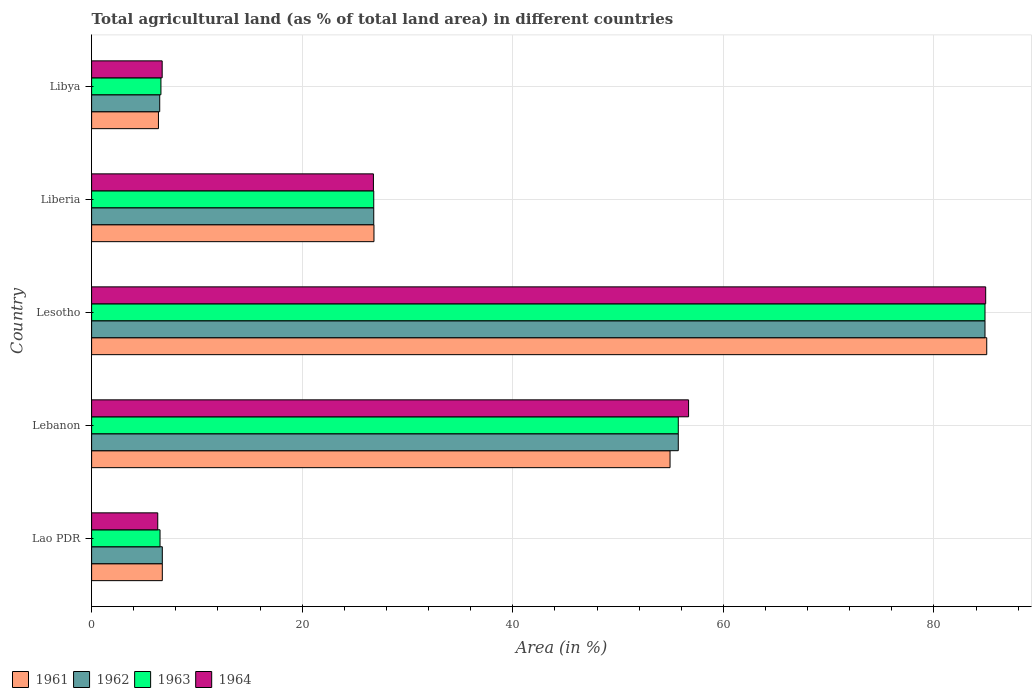Are the number of bars per tick equal to the number of legend labels?
Give a very brief answer. Yes. How many bars are there on the 4th tick from the bottom?
Your answer should be very brief. 4. What is the label of the 2nd group of bars from the top?
Keep it short and to the point. Liberia. In how many cases, is the number of bars for a given country not equal to the number of legend labels?
Make the answer very short. 0. What is the percentage of agricultural land in 1962 in Lesotho?
Offer a very short reply. 84.85. Across all countries, what is the maximum percentage of agricultural land in 1964?
Provide a short and direct response. 84.91. Across all countries, what is the minimum percentage of agricultural land in 1964?
Offer a terse response. 6.28. In which country was the percentage of agricultural land in 1963 maximum?
Provide a short and direct response. Lesotho. In which country was the percentage of agricultural land in 1964 minimum?
Your answer should be very brief. Lao PDR. What is the total percentage of agricultural land in 1964 in the graph?
Make the answer very short. 181.36. What is the difference between the percentage of agricultural land in 1961 in Lao PDR and that in Lebanon?
Offer a very short reply. -48.22. What is the difference between the percentage of agricultural land in 1963 in Lebanon and the percentage of agricultural land in 1962 in Libya?
Your answer should be compact. 49.25. What is the average percentage of agricultural land in 1961 per country?
Your answer should be compact. 35.97. What is the difference between the percentage of agricultural land in 1964 and percentage of agricultural land in 1962 in Lebanon?
Your answer should be compact. 0.98. What is the ratio of the percentage of agricultural land in 1962 in Lao PDR to that in Lebanon?
Your answer should be very brief. 0.12. What is the difference between the highest and the second highest percentage of agricultural land in 1962?
Your answer should be very brief. 29.13. What is the difference between the highest and the lowest percentage of agricultural land in 1962?
Your answer should be compact. 78.38. In how many countries, is the percentage of agricultural land in 1962 greater than the average percentage of agricultural land in 1962 taken over all countries?
Provide a succinct answer. 2. Is it the case that in every country, the sum of the percentage of agricultural land in 1961 and percentage of agricultural land in 1964 is greater than the percentage of agricultural land in 1963?
Your response must be concise. Yes. How many bars are there?
Your answer should be very brief. 20. Are all the bars in the graph horizontal?
Your answer should be compact. Yes. How many countries are there in the graph?
Your answer should be very brief. 5. What is the difference between two consecutive major ticks on the X-axis?
Your answer should be very brief. 20. Does the graph contain any zero values?
Your answer should be compact. No. How many legend labels are there?
Provide a short and direct response. 4. How are the legend labels stacked?
Your answer should be compact. Horizontal. What is the title of the graph?
Provide a short and direct response. Total agricultural land (as % of total land area) in different countries. What is the label or title of the X-axis?
Your answer should be very brief. Area (in %). What is the Area (in %) in 1961 in Lao PDR?
Offer a terse response. 6.72. What is the Area (in %) of 1962 in Lao PDR?
Offer a very short reply. 6.72. What is the Area (in %) of 1963 in Lao PDR?
Keep it short and to the point. 6.5. What is the Area (in %) in 1964 in Lao PDR?
Offer a terse response. 6.28. What is the Area (in %) of 1961 in Lebanon?
Offer a very short reply. 54.94. What is the Area (in %) in 1962 in Lebanon?
Keep it short and to the point. 55.72. What is the Area (in %) of 1963 in Lebanon?
Your response must be concise. 55.72. What is the Area (in %) of 1964 in Lebanon?
Your answer should be compact. 56.7. What is the Area (in %) of 1961 in Lesotho?
Provide a short and direct response. 85.01. What is the Area (in %) of 1962 in Lesotho?
Your response must be concise. 84.85. What is the Area (in %) in 1963 in Lesotho?
Provide a short and direct response. 84.85. What is the Area (in %) in 1964 in Lesotho?
Make the answer very short. 84.91. What is the Area (in %) of 1961 in Liberia?
Your answer should be very brief. 26.82. What is the Area (in %) in 1962 in Liberia?
Ensure brevity in your answer.  26.8. What is the Area (in %) in 1963 in Liberia?
Your answer should be very brief. 26.8. What is the Area (in %) in 1964 in Liberia?
Provide a short and direct response. 26.76. What is the Area (in %) of 1961 in Libya?
Ensure brevity in your answer.  6.35. What is the Area (in %) of 1962 in Libya?
Your response must be concise. 6.47. What is the Area (in %) in 1963 in Libya?
Your answer should be compact. 6.58. What is the Area (in %) in 1964 in Libya?
Make the answer very short. 6.7. Across all countries, what is the maximum Area (in %) in 1961?
Keep it short and to the point. 85.01. Across all countries, what is the maximum Area (in %) of 1962?
Your response must be concise. 84.85. Across all countries, what is the maximum Area (in %) in 1963?
Your answer should be compact. 84.85. Across all countries, what is the maximum Area (in %) of 1964?
Offer a terse response. 84.91. Across all countries, what is the minimum Area (in %) of 1961?
Keep it short and to the point. 6.35. Across all countries, what is the minimum Area (in %) of 1962?
Offer a terse response. 6.47. Across all countries, what is the minimum Area (in %) in 1963?
Offer a terse response. 6.5. Across all countries, what is the minimum Area (in %) in 1964?
Give a very brief answer. 6.28. What is the total Area (in %) of 1961 in the graph?
Keep it short and to the point. 179.83. What is the total Area (in %) in 1962 in the graph?
Offer a terse response. 180.55. What is the total Area (in %) of 1963 in the graph?
Provide a succinct answer. 180.45. What is the total Area (in %) of 1964 in the graph?
Provide a succinct answer. 181.36. What is the difference between the Area (in %) of 1961 in Lao PDR and that in Lebanon?
Offer a very short reply. -48.22. What is the difference between the Area (in %) in 1962 in Lao PDR and that in Lebanon?
Offer a terse response. -49. What is the difference between the Area (in %) of 1963 in Lao PDR and that in Lebanon?
Provide a succinct answer. -49.22. What is the difference between the Area (in %) of 1964 in Lao PDR and that in Lebanon?
Offer a terse response. -50.41. What is the difference between the Area (in %) of 1961 in Lao PDR and that in Lesotho?
Give a very brief answer. -78.3. What is the difference between the Area (in %) in 1962 in Lao PDR and that in Lesotho?
Ensure brevity in your answer.  -78.13. What is the difference between the Area (in %) in 1963 in Lao PDR and that in Lesotho?
Give a very brief answer. -78.35. What is the difference between the Area (in %) in 1964 in Lao PDR and that in Lesotho?
Ensure brevity in your answer.  -78.63. What is the difference between the Area (in %) in 1961 in Lao PDR and that in Liberia?
Your answer should be compact. -20.1. What is the difference between the Area (in %) of 1962 in Lao PDR and that in Liberia?
Your answer should be very brief. -20.08. What is the difference between the Area (in %) in 1963 in Lao PDR and that in Liberia?
Offer a terse response. -20.3. What is the difference between the Area (in %) of 1964 in Lao PDR and that in Liberia?
Provide a succinct answer. -20.48. What is the difference between the Area (in %) in 1961 in Lao PDR and that in Libya?
Give a very brief answer. 0.37. What is the difference between the Area (in %) in 1962 in Lao PDR and that in Libya?
Provide a succinct answer. 0.25. What is the difference between the Area (in %) in 1963 in Lao PDR and that in Libya?
Provide a short and direct response. -0.09. What is the difference between the Area (in %) of 1964 in Lao PDR and that in Libya?
Your answer should be compact. -0.42. What is the difference between the Area (in %) of 1961 in Lebanon and that in Lesotho?
Offer a very short reply. -30.08. What is the difference between the Area (in %) of 1962 in Lebanon and that in Lesotho?
Provide a short and direct response. -29.13. What is the difference between the Area (in %) in 1963 in Lebanon and that in Lesotho?
Provide a short and direct response. -29.13. What is the difference between the Area (in %) in 1964 in Lebanon and that in Lesotho?
Keep it short and to the point. -28.22. What is the difference between the Area (in %) in 1961 in Lebanon and that in Liberia?
Make the answer very short. 28.12. What is the difference between the Area (in %) of 1962 in Lebanon and that in Liberia?
Give a very brief answer. 28.92. What is the difference between the Area (in %) of 1963 in Lebanon and that in Liberia?
Ensure brevity in your answer.  28.92. What is the difference between the Area (in %) of 1964 in Lebanon and that in Liberia?
Your response must be concise. 29.93. What is the difference between the Area (in %) in 1961 in Lebanon and that in Libya?
Your answer should be very brief. 48.59. What is the difference between the Area (in %) in 1962 in Lebanon and that in Libya?
Give a very brief answer. 49.25. What is the difference between the Area (in %) in 1963 in Lebanon and that in Libya?
Provide a succinct answer. 49.13. What is the difference between the Area (in %) in 1964 in Lebanon and that in Libya?
Provide a short and direct response. 49.99. What is the difference between the Area (in %) in 1961 in Lesotho and that in Liberia?
Your response must be concise. 58.2. What is the difference between the Area (in %) in 1962 in Lesotho and that in Liberia?
Your answer should be very brief. 58.05. What is the difference between the Area (in %) of 1963 in Lesotho and that in Liberia?
Provide a short and direct response. 58.05. What is the difference between the Area (in %) in 1964 in Lesotho and that in Liberia?
Provide a short and direct response. 58.15. What is the difference between the Area (in %) of 1961 in Lesotho and that in Libya?
Keep it short and to the point. 78.66. What is the difference between the Area (in %) in 1962 in Lesotho and that in Libya?
Your response must be concise. 78.38. What is the difference between the Area (in %) in 1963 in Lesotho and that in Libya?
Offer a very short reply. 78.26. What is the difference between the Area (in %) of 1964 in Lesotho and that in Libya?
Provide a succinct answer. 78.21. What is the difference between the Area (in %) of 1961 in Liberia and that in Libya?
Make the answer very short. 20.47. What is the difference between the Area (in %) in 1962 in Liberia and that in Libya?
Ensure brevity in your answer.  20.33. What is the difference between the Area (in %) of 1963 in Liberia and that in Libya?
Make the answer very short. 20.21. What is the difference between the Area (in %) of 1964 in Liberia and that in Libya?
Offer a very short reply. 20.06. What is the difference between the Area (in %) of 1961 in Lao PDR and the Area (in %) of 1962 in Lebanon?
Your response must be concise. -49. What is the difference between the Area (in %) of 1961 in Lao PDR and the Area (in %) of 1963 in Lebanon?
Offer a very short reply. -49. What is the difference between the Area (in %) in 1961 in Lao PDR and the Area (in %) in 1964 in Lebanon?
Your answer should be very brief. -49.98. What is the difference between the Area (in %) of 1962 in Lao PDR and the Area (in %) of 1963 in Lebanon?
Your answer should be very brief. -49. What is the difference between the Area (in %) of 1962 in Lao PDR and the Area (in %) of 1964 in Lebanon?
Offer a very short reply. -49.98. What is the difference between the Area (in %) of 1963 in Lao PDR and the Area (in %) of 1964 in Lebanon?
Keep it short and to the point. -50.2. What is the difference between the Area (in %) of 1961 in Lao PDR and the Area (in %) of 1962 in Lesotho?
Your answer should be compact. -78.13. What is the difference between the Area (in %) in 1961 in Lao PDR and the Area (in %) in 1963 in Lesotho?
Provide a succinct answer. -78.13. What is the difference between the Area (in %) of 1961 in Lao PDR and the Area (in %) of 1964 in Lesotho?
Give a very brief answer. -78.2. What is the difference between the Area (in %) of 1962 in Lao PDR and the Area (in %) of 1963 in Lesotho?
Your answer should be compact. -78.13. What is the difference between the Area (in %) of 1962 in Lao PDR and the Area (in %) of 1964 in Lesotho?
Your answer should be compact. -78.2. What is the difference between the Area (in %) of 1963 in Lao PDR and the Area (in %) of 1964 in Lesotho?
Make the answer very short. -78.42. What is the difference between the Area (in %) in 1961 in Lao PDR and the Area (in %) in 1962 in Liberia?
Provide a succinct answer. -20.08. What is the difference between the Area (in %) in 1961 in Lao PDR and the Area (in %) in 1963 in Liberia?
Ensure brevity in your answer.  -20.08. What is the difference between the Area (in %) in 1961 in Lao PDR and the Area (in %) in 1964 in Liberia?
Offer a very short reply. -20.05. What is the difference between the Area (in %) of 1962 in Lao PDR and the Area (in %) of 1963 in Liberia?
Ensure brevity in your answer.  -20.08. What is the difference between the Area (in %) in 1962 in Lao PDR and the Area (in %) in 1964 in Liberia?
Your response must be concise. -20.05. What is the difference between the Area (in %) of 1963 in Lao PDR and the Area (in %) of 1964 in Liberia?
Keep it short and to the point. -20.27. What is the difference between the Area (in %) of 1961 in Lao PDR and the Area (in %) of 1962 in Libya?
Offer a very short reply. 0.25. What is the difference between the Area (in %) of 1961 in Lao PDR and the Area (in %) of 1963 in Libya?
Make the answer very short. 0.13. What is the difference between the Area (in %) of 1961 in Lao PDR and the Area (in %) of 1964 in Libya?
Give a very brief answer. 0.01. What is the difference between the Area (in %) in 1962 in Lao PDR and the Area (in %) in 1963 in Libya?
Ensure brevity in your answer.  0.13. What is the difference between the Area (in %) of 1962 in Lao PDR and the Area (in %) of 1964 in Libya?
Ensure brevity in your answer.  0.01. What is the difference between the Area (in %) in 1963 in Lao PDR and the Area (in %) in 1964 in Libya?
Ensure brevity in your answer.  -0.2. What is the difference between the Area (in %) in 1961 in Lebanon and the Area (in %) in 1962 in Lesotho?
Provide a short and direct response. -29.91. What is the difference between the Area (in %) of 1961 in Lebanon and the Area (in %) of 1963 in Lesotho?
Provide a succinct answer. -29.91. What is the difference between the Area (in %) in 1961 in Lebanon and the Area (in %) in 1964 in Lesotho?
Make the answer very short. -29.98. What is the difference between the Area (in %) in 1962 in Lebanon and the Area (in %) in 1963 in Lesotho?
Your answer should be very brief. -29.13. What is the difference between the Area (in %) in 1962 in Lebanon and the Area (in %) in 1964 in Lesotho?
Provide a short and direct response. -29.2. What is the difference between the Area (in %) of 1963 in Lebanon and the Area (in %) of 1964 in Lesotho?
Your response must be concise. -29.2. What is the difference between the Area (in %) in 1961 in Lebanon and the Area (in %) in 1962 in Liberia?
Ensure brevity in your answer.  28.14. What is the difference between the Area (in %) of 1961 in Lebanon and the Area (in %) of 1963 in Liberia?
Provide a succinct answer. 28.14. What is the difference between the Area (in %) of 1961 in Lebanon and the Area (in %) of 1964 in Liberia?
Offer a very short reply. 28.17. What is the difference between the Area (in %) in 1962 in Lebanon and the Area (in %) in 1963 in Liberia?
Your answer should be compact. 28.92. What is the difference between the Area (in %) in 1962 in Lebanon and the Area (in %) in 1964 in Liberia?
Keep it short and to the point. 28.95. What is the difference between the Area (in %) in 1963 in Lebanon and the Area (in %) in 1964 in Liberia?
Provide a succinct answer. 28.95. What is the difference between the Area (in %) in 1961 in Lebanon and the Area (in %) in 1962 in Libya?
Provide a short and direct response. 48.47. What is the difference between the Area (in %) in 1961 in Lebanon and the Area (in %) in 1963 in Libya?
Keep it short and to the point. 48.35. What is the difference between the Area (in %) in 1961 in Lebanon and the Area (in %) in 1964 in Libya?
Your response must be concise. 48.23. What is the difference between the Area (in %) in 1962 in Lebanon and the Area (in %) in 1963 in Libya?
Offer a very short reply. 49.13. What is the difference between the Area (in %) of 1962 in Lebanon and the Area (in %) of 1964 in Libya?
Give a very brief answer. 49.02. What is the difference between the Area (in %) of 1963 in Lebanon and the Area (in %) of 1964 in Libya?
Your answer should be very brief. 49.02. What is the difference between the Area (in %) of 1961 in Lesotho and the Area (in %) of 1962 in Liberia?
Offer a terse response. 58.22. What is the difference between the Area (in %) in 1961 in Lesotho and the Area (in %) in 1963 in Liberia?
Ensure brevity in your answer.  58.22. What is the difference between the Area (in %) in 1961 in Lesotho and the Area (in %) in 1964 in Liberia?
Offer a very short reply. 58.25. What is the difference between the Area (in %) of 1962 in Lesotho and the Area (in %) of 1963 in Liberia?
Give a very brief answer. 58.05. What is the difference between the Area (in %) in 1962 in Lesotho and the Area (in %) in 1964 in Liberia?
Provide a short and direct response. 58.08. What is the difference between the Area (in %) of 1963 in Lesotho and the Area (in %) of 1964 in Liberia?
Keep it short and to the point. 58.08. What is the difference between the Area (in %) of 1961 in Lesotho and the Area (in %) of 1962 in Libya?
Offer a very short reply. 78.54. What is the difference between the Area (in %) in 1961 in Lesotho and the Area (in %) in 1963 in Libya?
Keep it short and to the point. 78.43. What is the difference between the Area (in %) of 1961 in Lesotho and the Area (in %) of 1964 in Libya?
Provide a succinct answer. 78.31. What is the difference between the Area (in %) in 1962 in Lesotho and the Area (in %) in 1963 in Libya?
Provide a short and direct response. 78.26. What is the difference between the Area (in %) of 1962 in Lesotho and the Area (in %) of 1964 in Libya?
Ensure brevity in your answer.  78.15. What is the difference between the Area (in %) in 1963 in Lesotho and the Area (in %) in 1964 in Libya?
Keep it short and to the point. 78.15. What is the difference between the Area (in %) of 1961 in Liberia and the Area (in %) of 1962 in Libya?
Offer a very short reply. 20.35. What is the difference between the Area (in %) of 1961 in Liberia and the Area (in %) of 1963 in Libya?
Provide a short and direct response. 20.23. What is the difference between the Area (in %) in 1961 in Liberia and the Area (in %) in 1964 in Libya?
Make the answer very short. 20.11. What is the difference between the Area (in %) of 1962 in Liberia and the Area (in %) of 1963 in Libya?
Ensure brevity in your answer.  20.21. What is the difference between the Area (in %) of 1962 in Liberia and the Area (in %) of 1964 in Libya?
Your response must be concise. 20.09. What is the difference between the Area (in %) in 1963 in Liberia and the Area (in %) in 1964 in Libya?
Offer a very short reply. 20.09. What is the average Area (in %) of 1961 per country?
Your answer should be compact. 35.97. What is the average Area (in %) in 1962 per country?
Offer a terse response. 36.11. What is the average Area (in %) in 1963 per country?
Ensure brevity in your answer.  36.09. What is the average Area (in %) of 1964 per country?
Give a very brief answer. 36.27. What is the difference between the Area (in %) of 1961 and Area (in %) of 1963 in Lao PDR?
Ensure brevity in your answer.  0.22. What is the difference between the Area (in %) in 1961 and Area (in %) in 1964 in Lao PDR?
Make the answer very short. 0.43. What is the difference between the Area (in %) of 1962 and Area (in %) of 1963 in Lao PDR?
Give a very brief answer. 0.22. What is the difference between the Area (in %) of 1962 and Area (in %) of 1964 in Lao PDR?
Ensure brevity in your answer.  0.43. What is the difference between the Area (in %) of 1963 and Area (in %) of 1964 in Lao PDR?
Provide a succinct answer. 0.22. What is the difference between the Area (in %) of 1961 and Area (in %) of 1962 in Lebanon?
Your answer should be compact. -0.78. What is the difference between the Area (in %) of 1961 and Area (in %) of 1963 in Lebanon?
Make the answer very short. -0.78. What is the difference between the Area (in %) of 1961 and Area (in %) of 1964 in Lebanon?
Make the answer very short. -1.76. What is the difference between the Area (in %) of 1962 and Area (in %) of 1963 in Lebanon?
Ensure brevity in your answer.  0. What is the difference between the Area (in %) in 1962 and Area (in %) in 1964 in Lebanon?
Your answer should be very brief. -0.98. What is the difference between the Area (in %) of 1963 and Area (in %) of 1964 in Lebanon?
Your answer should be compact. -0.98. What is the difference between the Area (in %) of 1961 and Area (in %) of 1962 in Lesotho?
Offer a very short reply. 0.16. What is the difference between the Area (in %) of 1961 and Area (in %) of 1963 in Lesotho?
Provide a short and direct response. 0.16. What is the difference between the Area (in %) in 1961 and Area (in %) in 1964 in Lesotho?
Give a very brief answer. 0.1. What is the difference between the Area (in %) in 1962 and Area (in %) in 1963 in Lesotho?
Ensure brevity in your answer.  0. What is the difference between the Area (in %) in 1962 and Area (in %) in 1964 in Lesotho?
Offer a very short reply. -0.07. What is the difference between the Area (in %) in 1963 and Area (in %) in 1964 in Lesotho?
Make the answer very short. -0.07. What is the difference between the Area (in %) of 1961 and Area (in %) of 1962 in Liberia?
Offer a terse response. 0.02. What is the difference between the Area (in %) of 1961 and Area (in %) of 1963 in Liberia?
Your answer should be compact. 0.02. What is the difference between the Area (in %) of 1961 and Area (in %) of 1964 in Liberia?
Your answer should be very brief. 0.05. What is the difference between the Area (in %) of 1962 and Area (in %) of 1964 in Liberia?
Your answer should be very brief. 0.03. What is the difference between the Area (in %) in 1963 and Area (in %) in 1964 in Liberia?
Offer a very short reply. 0.03. What is the difference between the Area (in %) in 1961 and Area (in %) in 1962 in Libya?
Make the answer very short. -0.12. What is the difference between the Area (in %) in 1961 and Area (in %) in 1963 in Libya?
Offer a terse response. -0.24. What is the difference between the Area (in %) in 1961 and Area (in %) in 1964 in Libya?
Provide a succinct answer. -0.35. What is the difference between the Area (in %) in 1962 and Area (in %) in 1963 in Libya?
Give a very brief answer. -0.11. What is the difference between the Area (in %) of 1962 and Area (in %) of 1964 in Libya?
Offer a terse response. -0.23. What is the difference between the Area (in %) in 1963 and Area (in %) in 1964 in Libya?
Offer a terse response. -0.12. What is the ratio of the Area (in %) of 1961 in Lao PDR to that in Lebanon?
Make the answer very short. 0.12. What is the ratio of the Area (in %) of 1962 in Lao PDR to that in Lebanon?
Offer a terse response. 0.12. What is the ratio of the Area (in %) of 1963 in Lao PDR to that in Lebanon?
Offer a terse response. 0.12. What is the ratio of the Area (in %) in 1964 in Lao PDR to that in Lebanon?
Provide a short and direct response. 0.11. What is the ratio of the Area (in %) of 1961 in Lao PDR to that in Lesotho?
Provide a short and direct response. 0.08. What is the ratio of the Area (in %) in 1962 in Lao PDR to that in Lesotho?
Provide a short and direct response. 0.08. What is the ratio of the Area (in %) in 1963 in Lao PDR to that in Lesotho?
Ensure brevity in your answer.  0.08. What is the ratio of the Area (in %) in 1964 in Lao PDR to that in Lesotho?
Your response must be concise. 0.07. What is the ratio of the Area (in %) in 1961 in Lao PDR to that in Liberia?
Your response must be concise. 0.25. What is the ratio of the Area (in %) in 1962 in Lao PDR to that in Liberia?
Provide a succinct answer. 0.25. What is the ratio of the Area (in %) in 1963 in Lao PDR to that in Liberia?
Provide a short and direct response. 0.24. What is the ratio of the Area (in %) of 1964 in Lao PDR to that in Liberia?
Your response must be concise. 0.23. What is the ratio of the Area (in %) in 1961 in Lao PDR to that in Libya?
Offer a terse response. 1.06. What is the ratio of the Area (in %) of 1962 in Lao PDR to that in Libya?
Ensure brevity in your answer.  1.04. What is the ratio of the Area (in %) of 1963 in Lao PDR to that in Libya?
Ensure brevity in your answer.  0.99. What is the ratio of the Area (in %) in 1964 in Lao PDR to that in Libya?
Your response must be concise. 0.94. What is the ratio of the Area (in %) of 1961 in Lebanon to that in Lesotho?
Offer a very short reply. 0.65. What is the ratio of the Area (in %) of 1962 in Lebanon to that in Lesotho?
Provide a succinct answer. 0.66. What is the ratio of the Area (in %) of 1963 in Lebanon to that in Lesotho?
Make the answer very short. 0.66. What is the ratio of the Area (in %) of 1964 in Lebanon to that in Lesotho?
Ensure brevity in your answer.  0.67. What is the ratio of the Area (in %) in 1961 in Lebanon to that in Liberia?
Provide a short and direct response. 2.05. What is the ratio of the Area (in %) in 1962 in Lebanon to that in Liberia?
Your response must be concise. 2.08. What is the ratio of the Area (in %) in 1963 in Lebanon to that in Liberia?
Offer a terse response. 2.08. What is the ratio of the Area (in %) of 1964 in Lebanon to that in Liberia?
Offer a very short reply. 2.12. What is the ratio of the Area (in %) in 1961 in Lebanon to that in Libya?
Keep it short and to the point. 8.65. What is the ratio of the Area (in %) of 1962 in Lebanon to that in Libya?
Provide a short and direct response. 8.61. What is the ratio of the Area (in %) of 1963 in Lebanon to that in Libya?
Your response must be concise. 8.46. What is the ratio of the Area (in %) in 1964 in Lebanon to that in Libya?
Ensure brevity in your answer.  8.46. What is the ratio of the Area (in %) in 1961 in Lesotho to that in Liberia?
Offer a very short reply. 3.17. What is the ratio of the Area (in %) in 1962 in Lesotho to that in Liberia?
Offer a very short reply. 3.17. What is the ratio of the Area (in %) of 1963 in Lesotho to that in Liberia?
Provide a succinct answer. 3.17. What is the ratio of the Area (in %) of 1964 in Lesotho to that in Liberia?
Offer a terse response. 3.17. What is the ratio of the Area (in %) of 1961 in Lesotho to that in Libya?
Give a very brief answer. 13.39. What is the ratio of the Area (in %) of 1962 in Lesotho to that in Libya?
Your answer should be very brief. 13.12. What is the ratio of the Area (in %) in 1963 in Lesotho to that in Libya?
Your response must be concise. 12.89. What is the ratio of the Area (in %) in 1964 in Lesotho to that in Libya?
Your response must be concise. 12.67. What is the ratio of the Area (in %) of 1961 in Liberia to that in Libya?
Provide a succinct answer. 4.22. What is the ratio of the Area (in %) of 1962 in Liberia to that in Libya?
Provide a succinct answer. 4.14. What is the ratio of the Area (in %) in 1963 in Liberia to that in Libya?
Provide a short and direct response. 4.07. What is the ratio of the Area (in %) of 1964 in Liberia to that in Libya?
Your answer should be compact. 3.99. What is the difference between the highest and the second highest Area (in %) of 1961?
Your answer should be very brief. 30.08. What is the difference between the highest and the second highest Area (in %) of 1962?
Ensure brevity in your answer.  29.13. What is the difference between the highest and the second highest Area (in %) in 1963?
Your response must be concise. 29.13. What is the difference between the highest and the second highest Area (in %) of 1964?
Keep it short and to the point. 28.22. What is the difference between the highest and the lowest Area (in %) in 1961?
Provide a succinct answer. 78.66. What is the difference between the highest and the lowest Area (in %) of 1962?
Offer a very short reply. 78.38. What is the difference between the highest and the lowest Area (in %) of 1963?
Provide a succinct answer. 78.35. What is the difference between the highest and the lowest Area (in %) in 1964?
Your answer should be very brief. 78.63. 